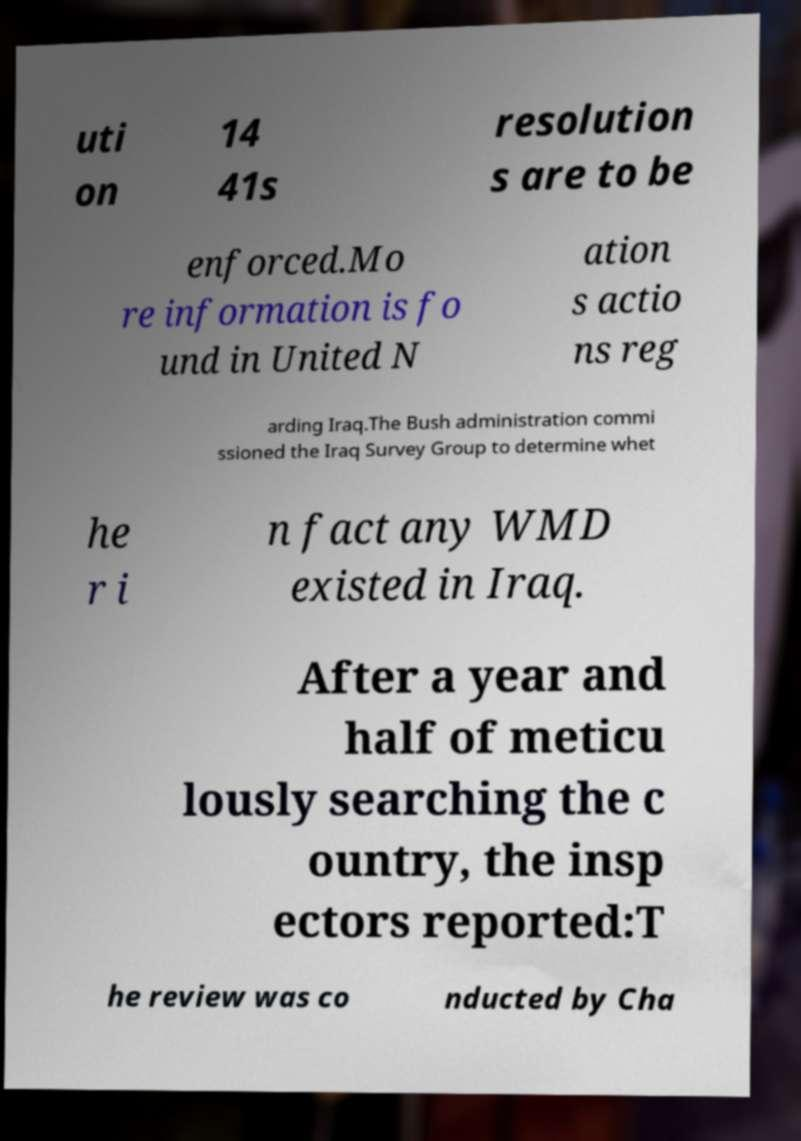Please read and relay the text visible in this image. What does it say? uti on 14 41s resolution s are to be enforced.Mo re information is fo und in United N ation s actio ns reg arding Iraq.The Bush administration commi ssioned the Iraq Survey Group to determine whet he r i n fact any WMD existed in Iraq. After a year and half of meticu lously searching the c ountry, the insp ectors reported:T he review was co nducted by Cha 